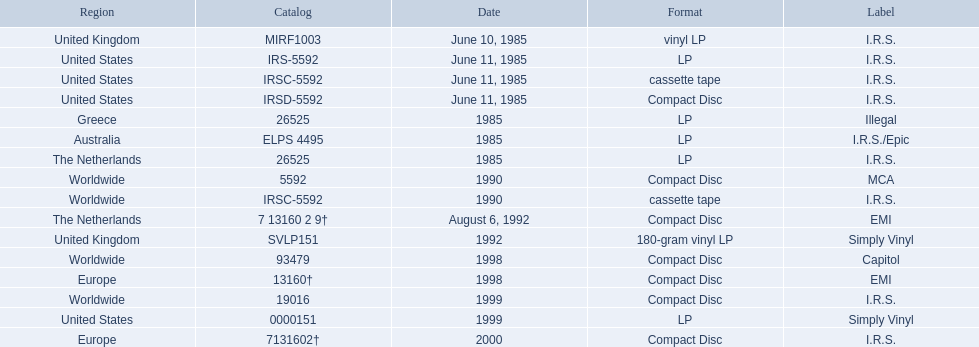In which regions was the fables of the reconstruction album released? United Kingdom, United States, United States, United States, Greece, Australia, The Netherlands, Worldwide, Worldwide, The Netherlands, United Kingdom, Worldwide, Europe, Worldwide, United States, Europe. And what were the release dates for those regions? June 10, 1985, June 11, 1985, June 11, 1985, June 11, 1985, 1985, 1985, 1985, 1990, 1990, August 6, 1992, 1992, 1998, 1998, 1999, 1999, 2000. And which region was listed after greece in 1985? Australia. 